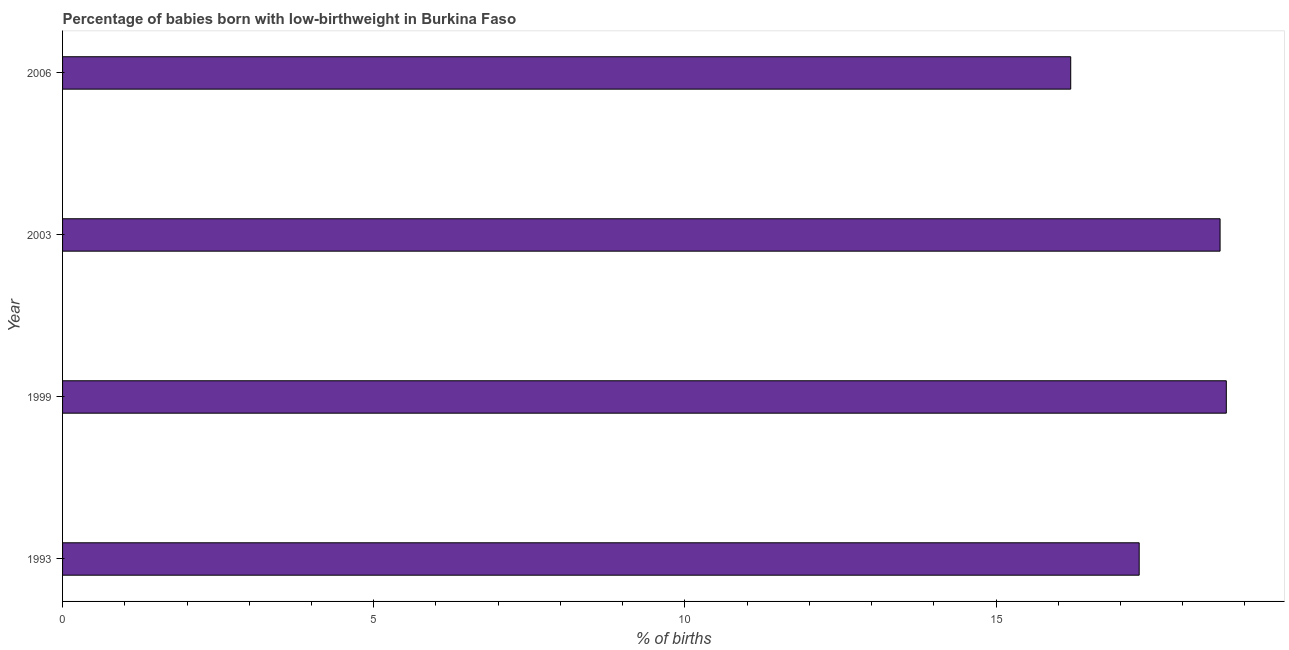Does the graph contain grids?
Provide a succinct answer. No. What is the title of the graph?
Your answer should be very brief. Percentage of babies born with low-birthweight in Burkina Faso. What is the label or title of the X-axis?
Your answer should be compact. % of births. What is the label or title of the Y-axis?
Your response must be concise. Year. Across all years, what is the maximum percentage of babies who were born with low-birthweight?
Your response must be concise. 18.7. In which year was the percentage of babies who were born with low-birthweight maximum?
Your answer should be very brief. 1999. What is the sum of the percentage of babies who were born with low-birthweight?
Give a very brief answer. 70.8. What is the median percentage of babies who were born with low-birthweight?
Your answer should be very brief. 17.95. Do a majority of the years between 2003 and 1993 (inclusive) have percentage of babies who were born with low-birthweight greater than 13 %?
Offer a terse response. Yes. What is the ratio of the percentage of babies who were born with low-birthweight in 1999 to that in 2006?
Provide a succinct answer. 1.15. Is the difference between the percentage of babies who were born with low-birthweight in 1993 and 2003 greater than the difference between any two years?
Make the answer very short. No. What is the difference between the highest and the second highest percentage of babies who were born with low-birthweight?
Offer a very short reply. 0.1. What is the difference between the highest and the lowest percentage of babies who were born with low-birthweight?
Keep it short and to the point. 2.5. How many bars are there?
Keep it short and to the point. 4. Are all the bars in the graph horizontal?
Give a very brief answer. Yes. How many years are there in the graph?
Offer a terse response. 4. What is the difference between two consecutive major ticks on the X-axis?
Your answer should be compact. 5. What is the % of births of 1993?
Give a very brief answer. 17.3. What is the % of births of 1999?
Ensure brevity in your answer.  18.7. What is the % of births of 2003?
Your response must be concise. 18.6. What is the difference between the % of births in 1993 and 2003?
Offer a terse response. -1.3. What is the difference between the % of births in 1993 and 2006?
Your response must be concise. 1.1. What is the difference between the % of births in 2003 and 2006?
Your answer should be compact. 2.4. What is the ratio of the % of births in 1993 to that in 1999?
Ensure brevity in your answer.  0.93. What is the ratio of the % of births in 1993 to that in 2006?
Your answer should be compact. 1.07. What is the ratio of the % of births in 1999 to that in 2006?
Give a very brief answer. 1.15. What is the ratio of the % of births in 2003 to that in 2006?
Your response must be concise. 1.15. 